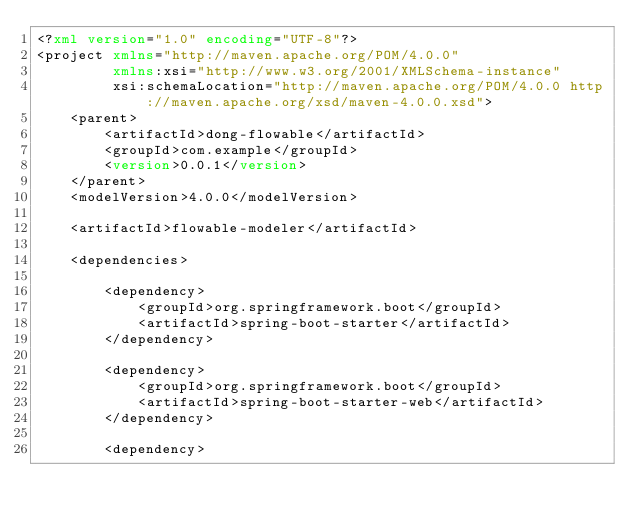<code> <loc_0><loc_0><loc_500><loc_500><_XML_><?xml version="1.0" encoding="UTF-8"?>
<project xmlns="http://maven.apache.org/POM/4.0.0"
         xmlns:xsi="http://www.w3.org/2001/XMLSchema-instance"
         xsi:schemaLocation="http://maven.apache.org/POM/4.0.0 http://maven.apache.org/xsd/maven-4.0.0.xsd">
    <parent>
        <artifactId>dong-flowable</artifactId>
        <groupId>com.example</groupId>
        <version>0.0.1</version>
    </parent>
    <modelVersion>4.0.0</modelVersion>

    <artifactId>flowable-modeler</artifactId>

    <dependencies>

        <dependency>
            <groupId>org.springframework.boot</groupId>
            <artifactId>spring-boot-starter</artifactId>
        </dependency>

        <dependency>
            <groupId>org.springframework.boot</groupId>
            <artifactId>spring-boot-starter-web</artifactId>
        </dependency>

        <dependency></code> 